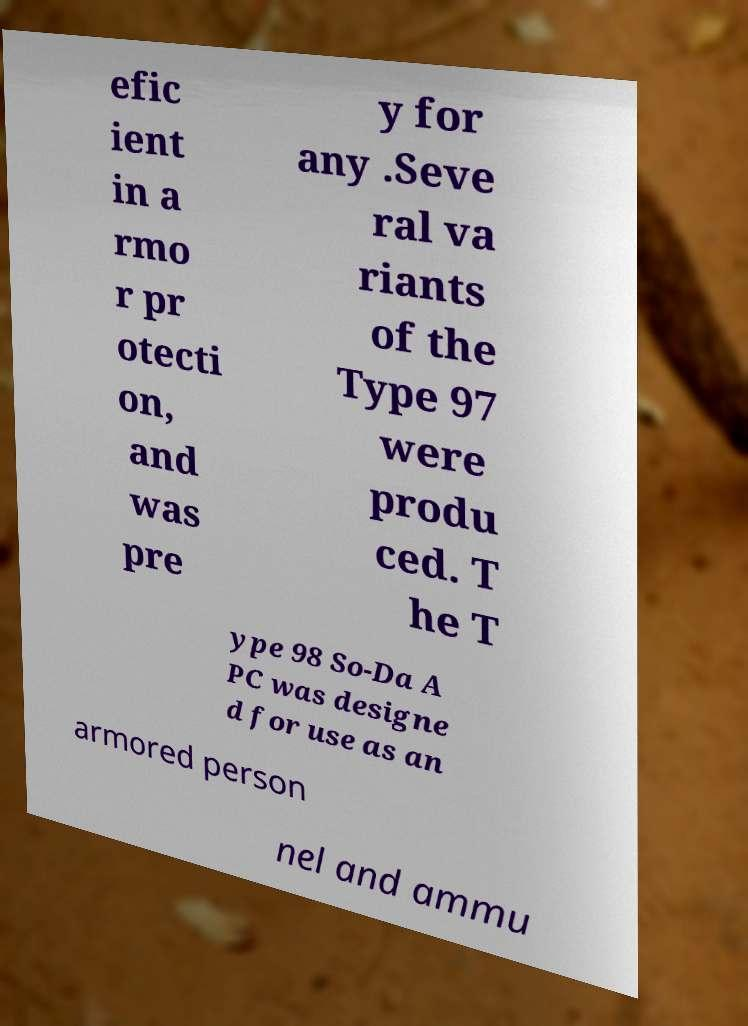Could you extract and type out the text from this image? efic ient in a rmo r pr otecti on, and was pre y for any .Seve ral va riants of the Type 97 were produ ced. T he T ype 98 So-Da A PC was designe d for use as an armored person nel and ammu 